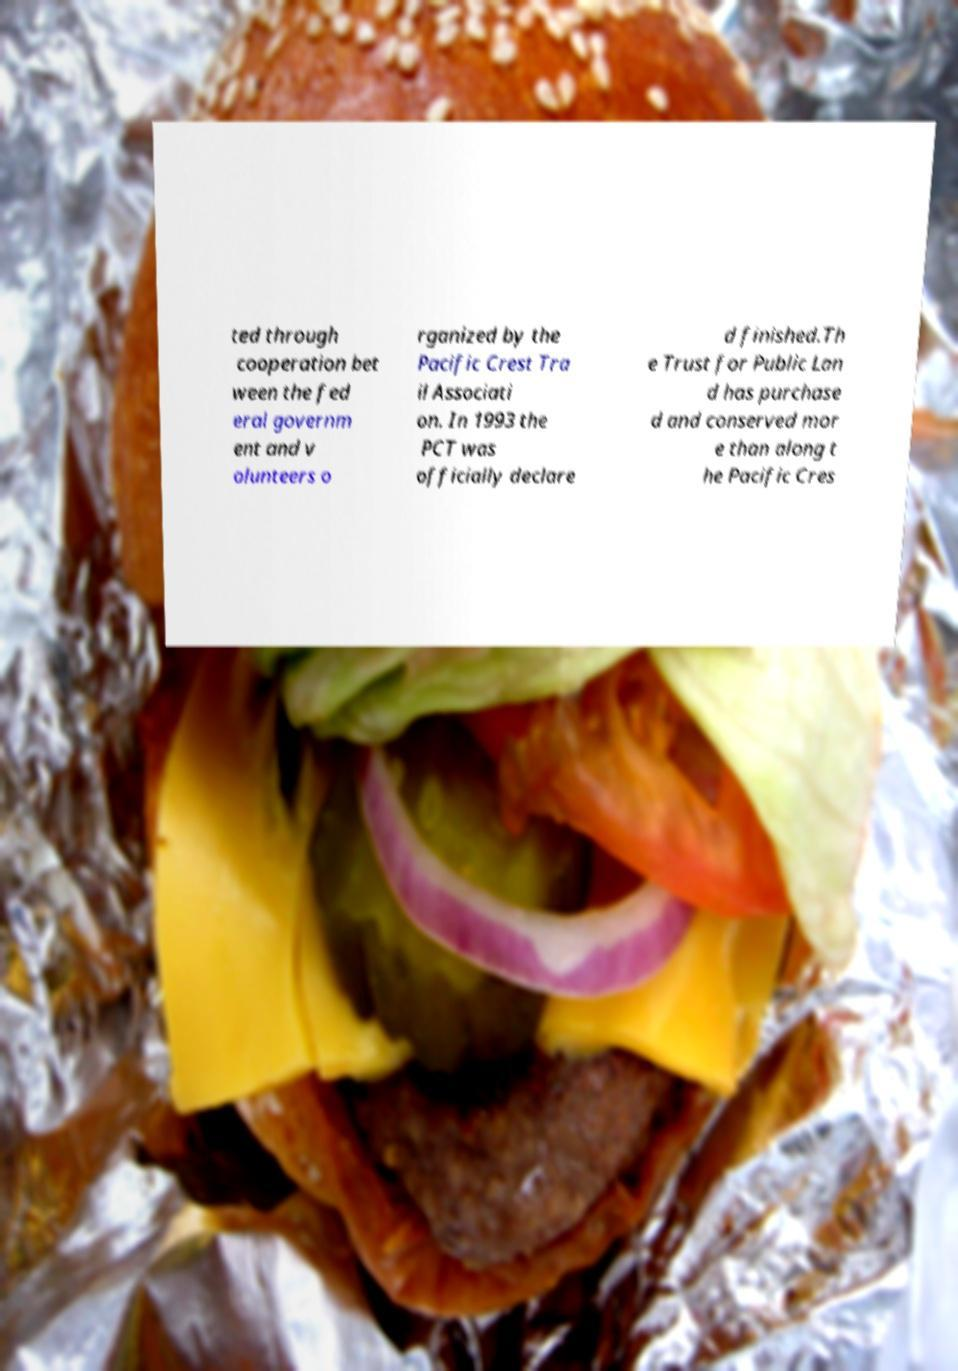What messages or text are displayed in this image? I need them in a readable, typed format. ted through cooperation bet ween the fed eral governm ent and v olunteers o rganized by the Pacific Crest Tra il Associati on. In 1993 the PCT was officially declare d finished.Th e Trust for Public Lan d has purchase d and conserved mor e than along t he Pacific Cres 